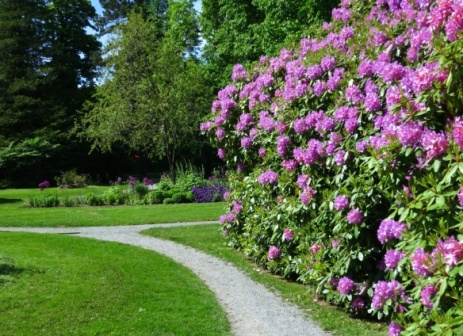Can you describe the possible sensory experiences one might enjoy while walking through this garden? Walking through this garden would engage multiple senses. Visually, the riot of colors from the pink flowers and greenery is soothing to the eyes. The scent of the flowers, particularly the pink blossoms, would likely be sweet and strong, particularly on a warm day. The sound of gravel crunching underfoot on the white stone path, coupled with the ambient sounds of nature, such as birdsong and the whisper of the breeze through the leaves, adds an auditory layer to the experience. Touching the cool leaves and textured barks of trees can further connect you with nature. 